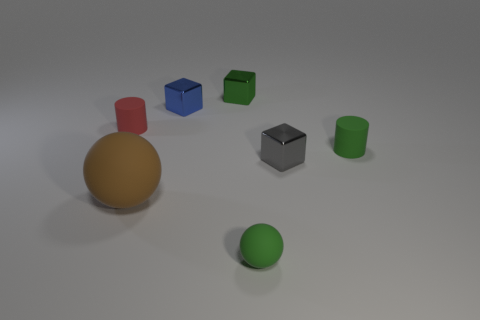What is the material of the blue thing?
Give a very brief answer. Metal. There is a rubber sphere on the right side of the brown rubber sphere; is it the same size as the large brown rubber sphere?
Provide a short and direct response. No. What number of things are either tiny metal blocks or small red cylinders?
Your answer should be compact. 4. There is a shiny object that is the same color as the small ball; what is its shape?
Your answer should be compact. Cube. What size is the rubber thing that is both to the left of the tiny green ball and to the right of the red matte cylinder?
Make the answer very short. Large. What number of small gray blocks are there?
Your answer should be compact. 1. What number of blocks are tiny metallic objects or large brown objects?
Provide a short and direct response. 3. What number of small things are to the left of the sphere that is to the right of the small blue object behind the gray shiny block?
Offer a terse response. 3. What is the color of the ball that is the same size as the blue shiny object?
Your response must be concise. Green. What number of other objects are the same color as the big matte object?
Offer a very short reply. 0. 